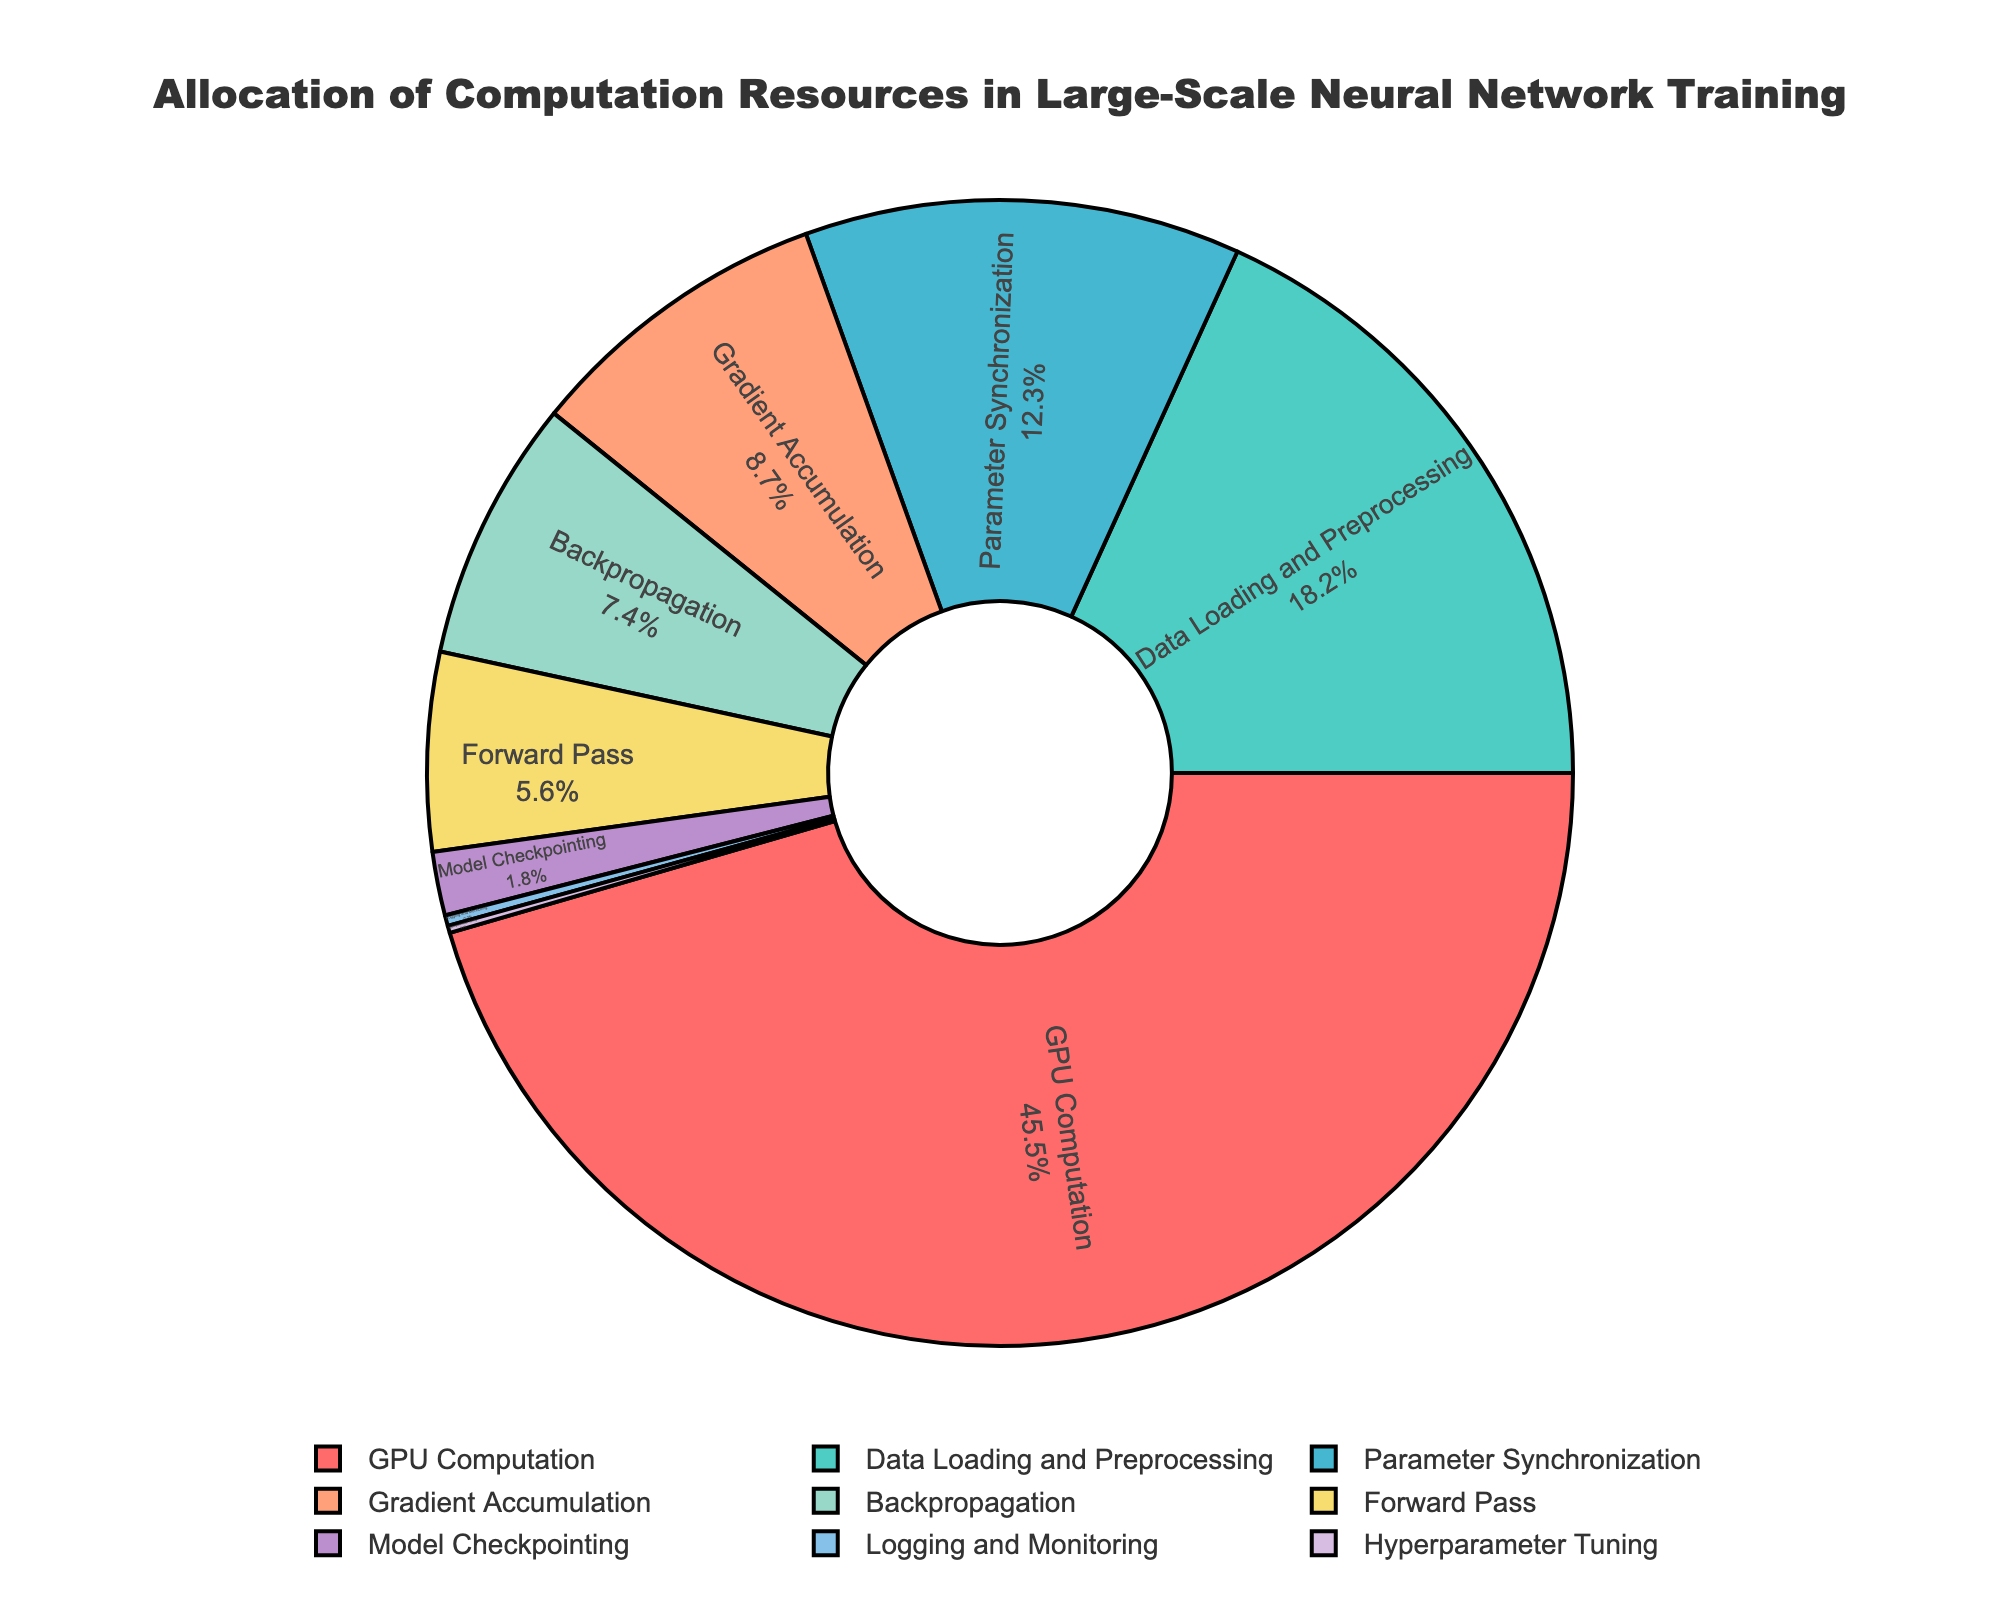What percentage of computation resources is allocated to the Forward Pass and Backpropagation combined? First, identify the percentages for the Forward Pass and Backpropagation from the pie chart, which are 5.6% and 7.4% respectively. Adding these values together gives 5.6 + 7.4 = 13.0%.
Answer: 13.0% Which resource has the smallest allocation, and what is its percentage? Identify the smallest section in the pie chart. The Logging and Monitoring section, with a percentage of 0.3%, is the smallest.
Answer: Logging and Monitoring, 0.3% Is the percentage of resources allocated to Data Loading and Preprocessing greater than the percentage allocated to Gradient Accumulation? Compare the two percentages from the pie chart: Data Loading and Preprocessing is 18.2%, and Gradient Accumulation is 8.7%. Since 18.2 is greater than 8.7, the answer is yes.
Answer: Yes What is the difference in percentage allocation between GPU Computation and Parameter Synchronization? From the pie chart, GPU Computation has 45.5% and Parameter Synchronization has 12.3%. The difference is 45.5 - 12.3 = 33.2%.
Answer: 33.2% Which resource category has the second-highest allocation of computation resources? The highest allocation is GPU Computation with 45.5%. The next highest after this is Data Loading and Preprocessing with 18.2%.
Answer: Data Loading and Preprocessing If you combine the percentages for Model Checkpointing and Hyperparameter Tuning, what is the total? From the pie chart, Model Checkpointing is 1.8% and Hyperparameter Tuning is 0.2%. Adding these values gives 1.8 + 0.2 = 2.0%.
Answer: 2.0% How much more percentage is allocated to Data Loading and Preprocessing compared to Logging and Monitoring? Data Loading and Preprocessing is 18.2% and Logging and Monitoring is 0.3%. The difference is 18.2 - 0.3 = 17.9%.
Answer: 17.9% Which two resources combined have an allocation close to that of GPU Computation? GPU Computation is 45.5%. Check pairs of allocations to find sums close to 45.5%. Data Loading and Preprocessing (18.2%) combined with Parameter Synchronization (12.3%) and Gradient Accumulation (8.7%) give 18.2 + 12.3 + 8.7 = 39.2%, which is close.
Answer: Data Loading and Preprocessing and Parameter Synchronization and Gradient Accumulation 